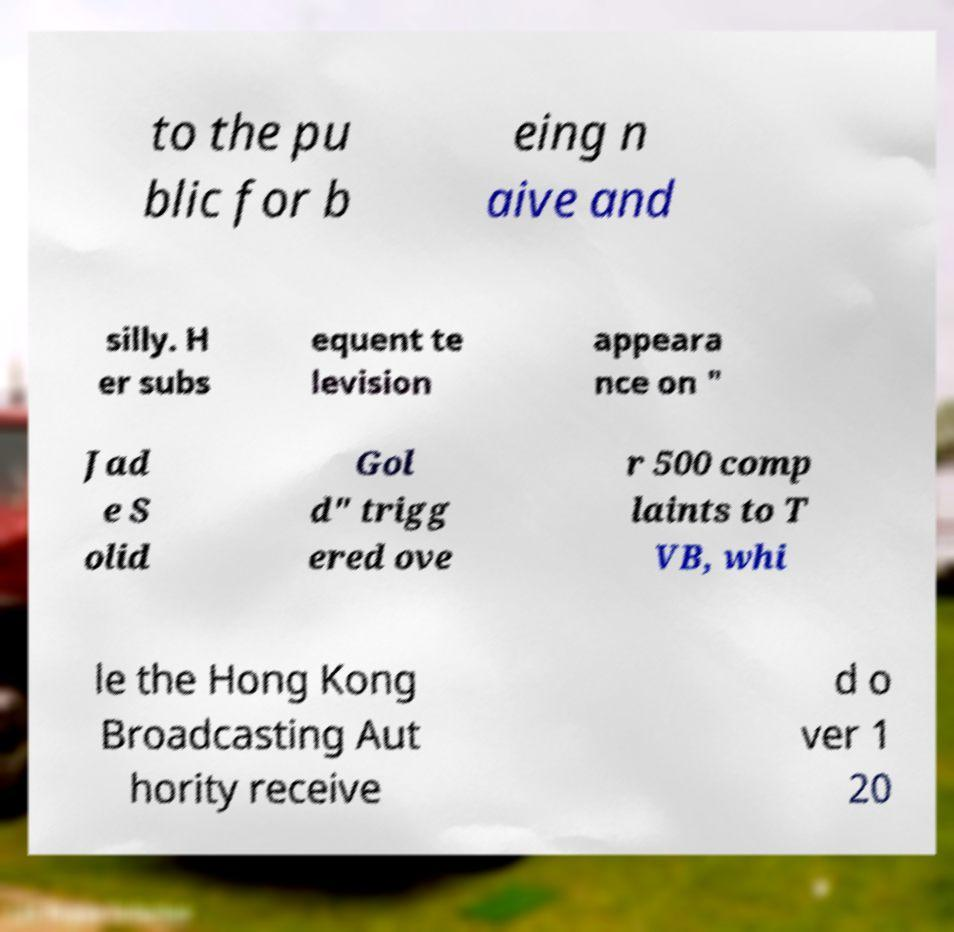What messages or text are displayed in this image? I need them in a readable, typed format. to the pu blic for b eing n aive and silly. H er subs equent te levision appeara nce on " Jad e S olid Gol d" trigg ered ove r 500 comp laints to T VB, whi le the Hong Kong Broadcasting Aut hority receive d o ver 1 20 